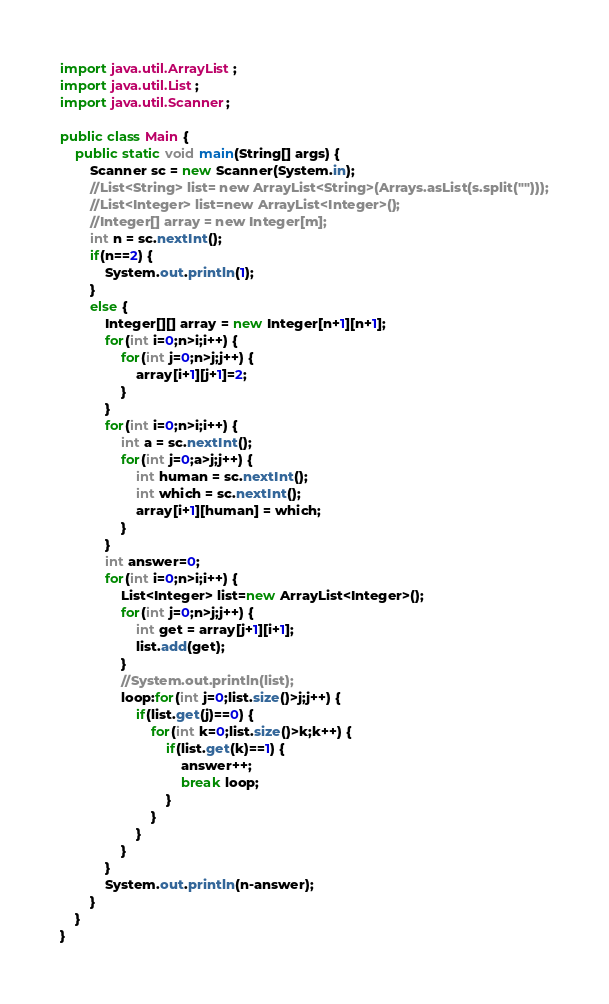<code> <loc_0><loc_0><loc_500><loc_500><_Java_>import java.util.ArrayList;
import java.util.List;
import java.util.Scanner;

public class Main {
	public static void main(String[] args) {
		Scanner sc = new Scanner(System.in);
		//List<String> list= new ArrayList<String>(Arrays.asList(s.split("")));
		//List<Integer> list=new ArrayList<Integer>();
		//Integer[] array = new Integer[m];
		int n = sc.nextInt();
		if(n==2) {
			System.out.println(1);
		}
		else {
			Integer[][] array = new Integer[n+1][n+1];
			for(int i=0;n>i;i++) {
				for(int j=0;n>j;j++) {
					array[i+1][j+1]=2;
				}
			}
			for(int i=0;n>i;i++) {
				int a = sc.nextInt();
				for(int j=0;a>j;j++) {
					int human = sc.nextInt();
					int which = sc.nextInt();
					array[i+1][human] = which;
				}
			}
			int answer=0;
			for(int i=0;n>i;i++) {
				List<Integer> list=new ArrayList<Integer>();
				for(int j=0;n>j;j++) {
					int get = array[j+1][i+1];
					list.add(get);
				}
				//System.out.println(list);
				loop:for(int j=0;list.size()>j;j++) {
					if(list.get(j)==0) {
						for(int k=0;list.size()>k;k++) {
							if(list.get(k)==1) {
								answer++;
								break loop;
							}
						}
					}
				}
			}
			System.out.println(n-answer);
		}
	}
}</code> 